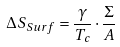Convert formula to latex. <formula><loc_0><loc_0><loc_500><loc_500>\Delta S _ { S u r f } = \frac { \gamma } { T _ { c } } \cdot \frac { \Sigma } { A }</formula> 